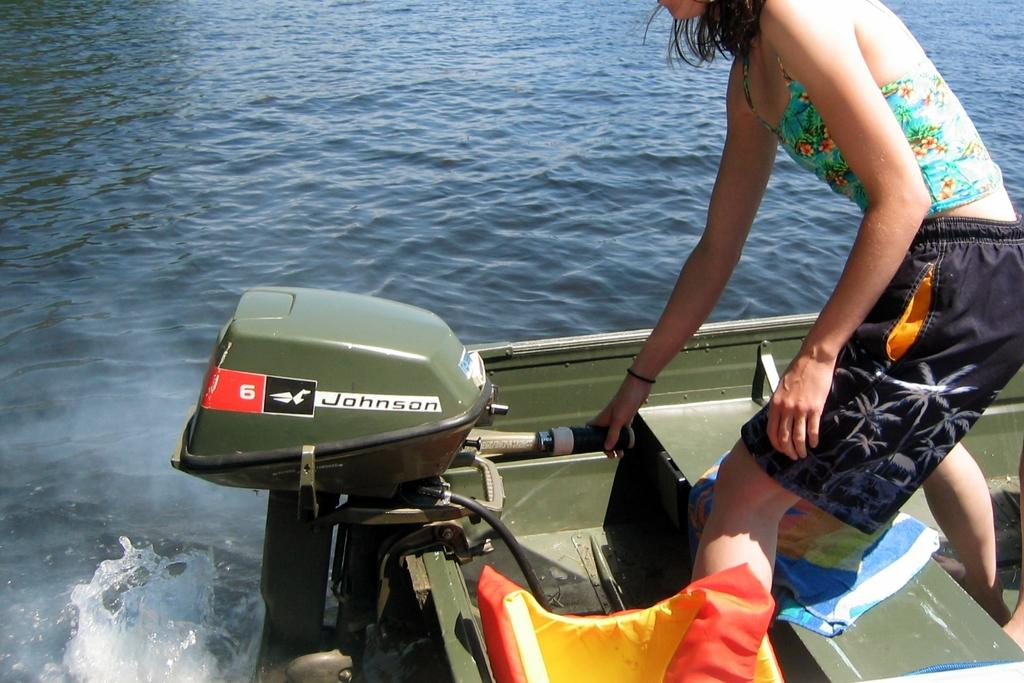Who is present in the image? There is a woman in the image. Where is the woman located in the image? The woman is on the right side of the image. What is the woman standing on in the image? The woman is on a green color boat. What is the boat on in the image? The green color boat is on water. What type of desk is visible in the image? There is no desk present in the image. What direction is the current flowing in the image? There is no reference to a current in the image, as it features a woman on a green color boat on water. 